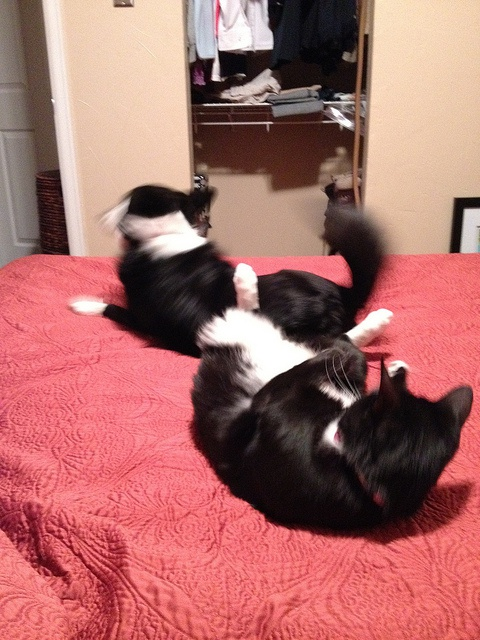Describe the objects in this image and their specific colors. I can see bed in gray, salmon, and black tones, cat in gray, black, white, and maroon tones, and cat in gray, black, white, and maroon tones in this image. 